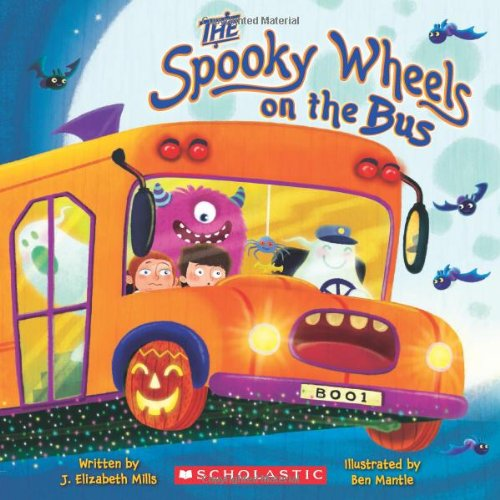Who wrote this book?
Answer the question using a single word or phrase. J. Elizabeth Mills What is the title of this book? The Spooky Wheels on the Bus What type of book is this? Children's Books Is this a kids book? Yes Is this an art related book? No 